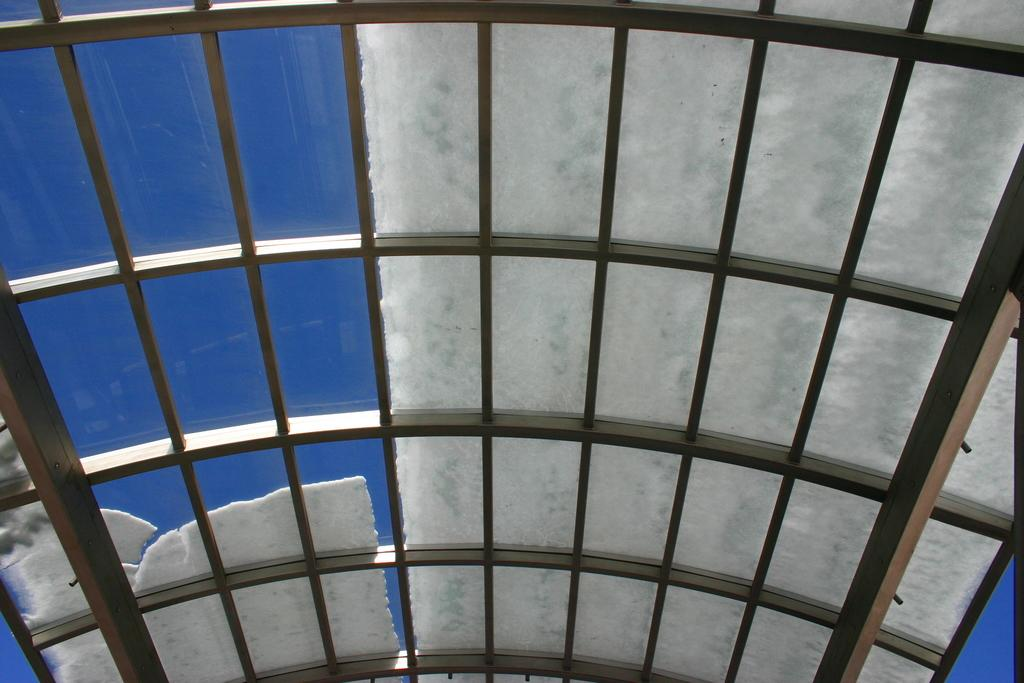What is located in the foreground of the image? There is a roof of a shed in the foreground of the image. What is covering the roof of the shed? There is snow on the roof of the shed. What type of belief system is practiced by the porter in the image? There is no porter present in the image, so it is not possible to determine what belief system they might practice. 